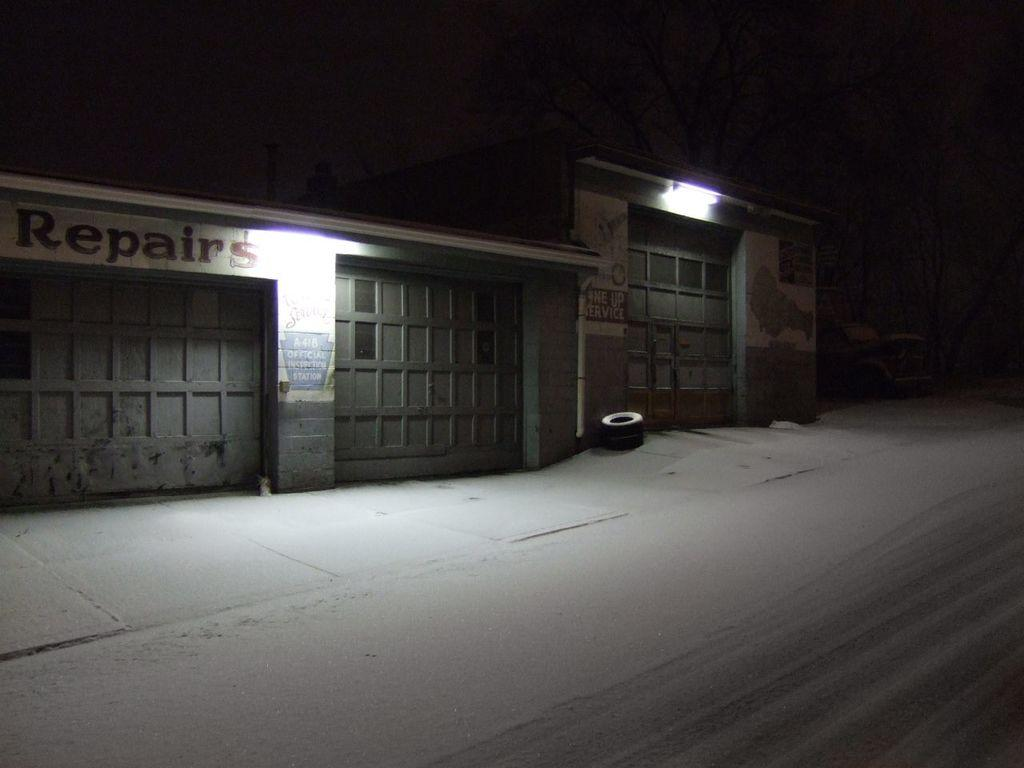What time of day is depicted in the image? The image is taken during night time. What type of structures can be seen in the image? There are buildings in the image. What objects are related to transportation in the image? There are tires and a vehicle in the image. What type of natural elements are present in the image? There are trees in the image. What type of path is visible in the image? There is a walking path in the image. What type of meat is being grilled on the quartz countertop in the image? There is no meat or quartz countertop present in the image. How does the elbow of the person in the image look like? There is no person or elbow visible in the image. 